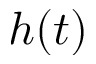<formula> <loc_0><loc_0><loc_500><loc_500>h ( t )</formula> 